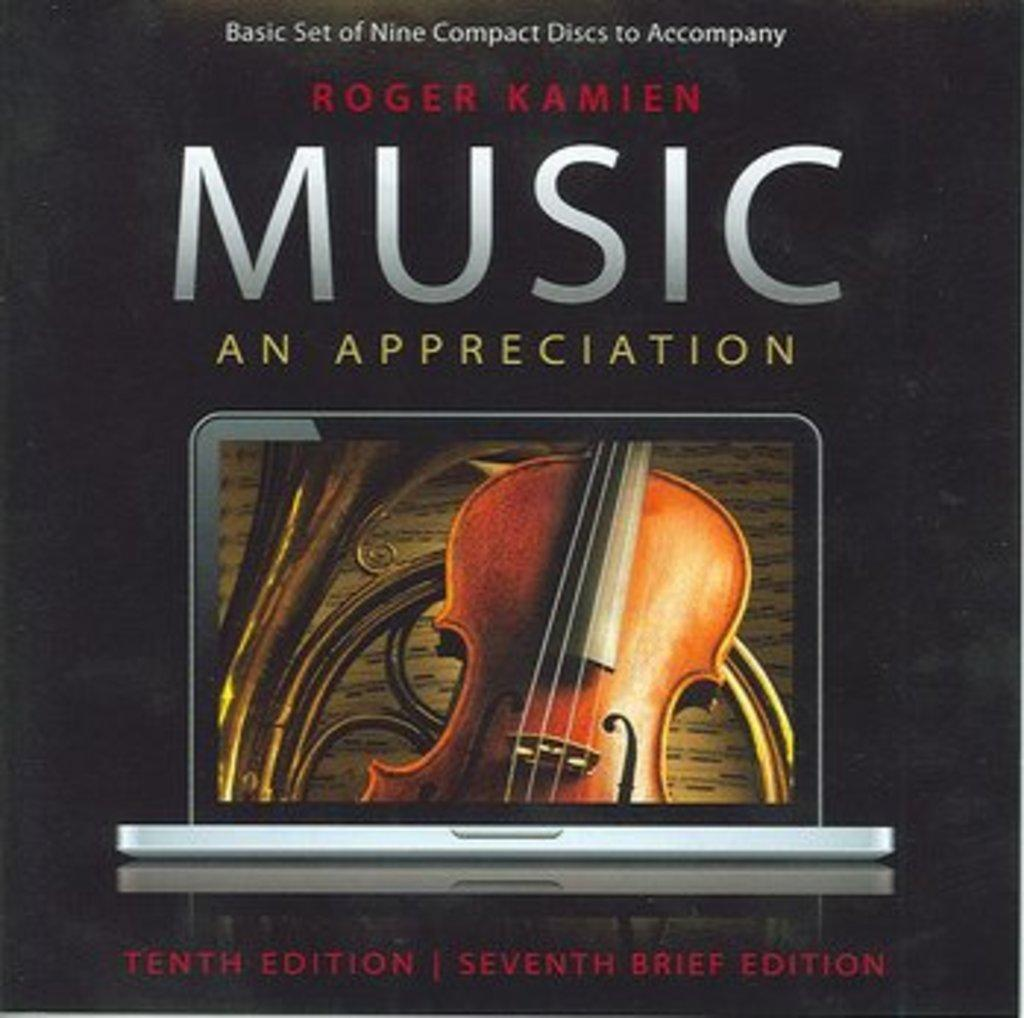<image>
Describe the image concisely. Cover showing a violin titled "Music An Appreciation". 